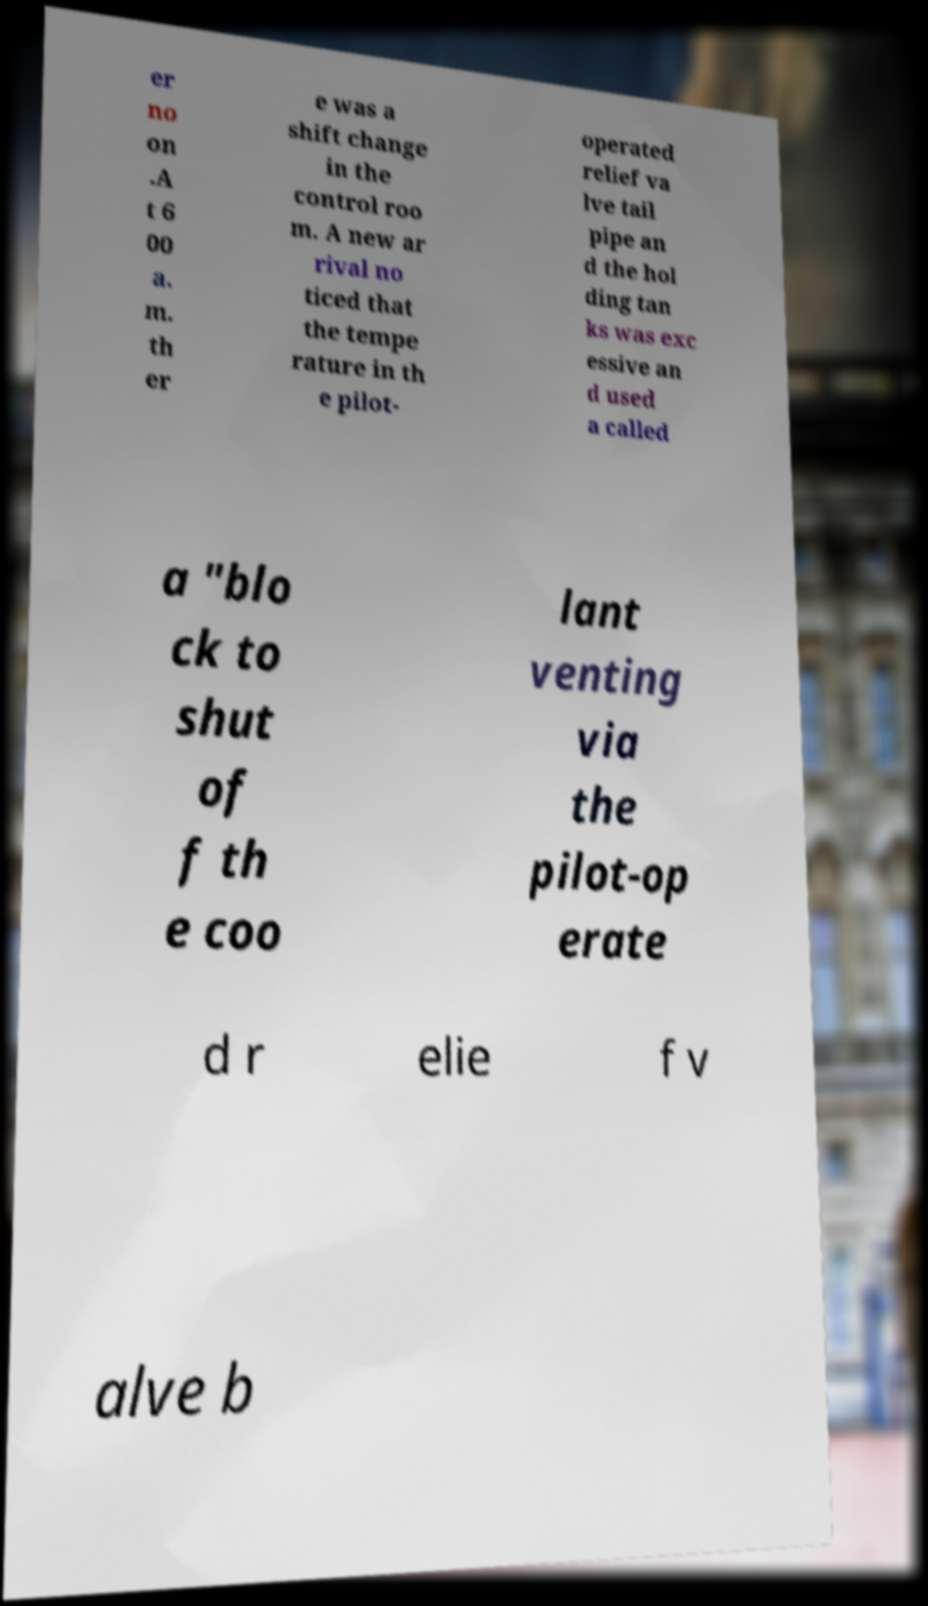There's text embedded in this image that I need extracted. Can you transcribe it verbatim? er no on .A t 6 00 a. m. th er e was a shift change in the control roo m. A new ar rival no ticed that the tempe rature in th e pilot- operated relief va lve tail pipe an d the hol ding tan ks was exc essive an d used a called a "blo ck to shut of f th e coo lant venting via the pilot-op erate d r elie f v alve b 